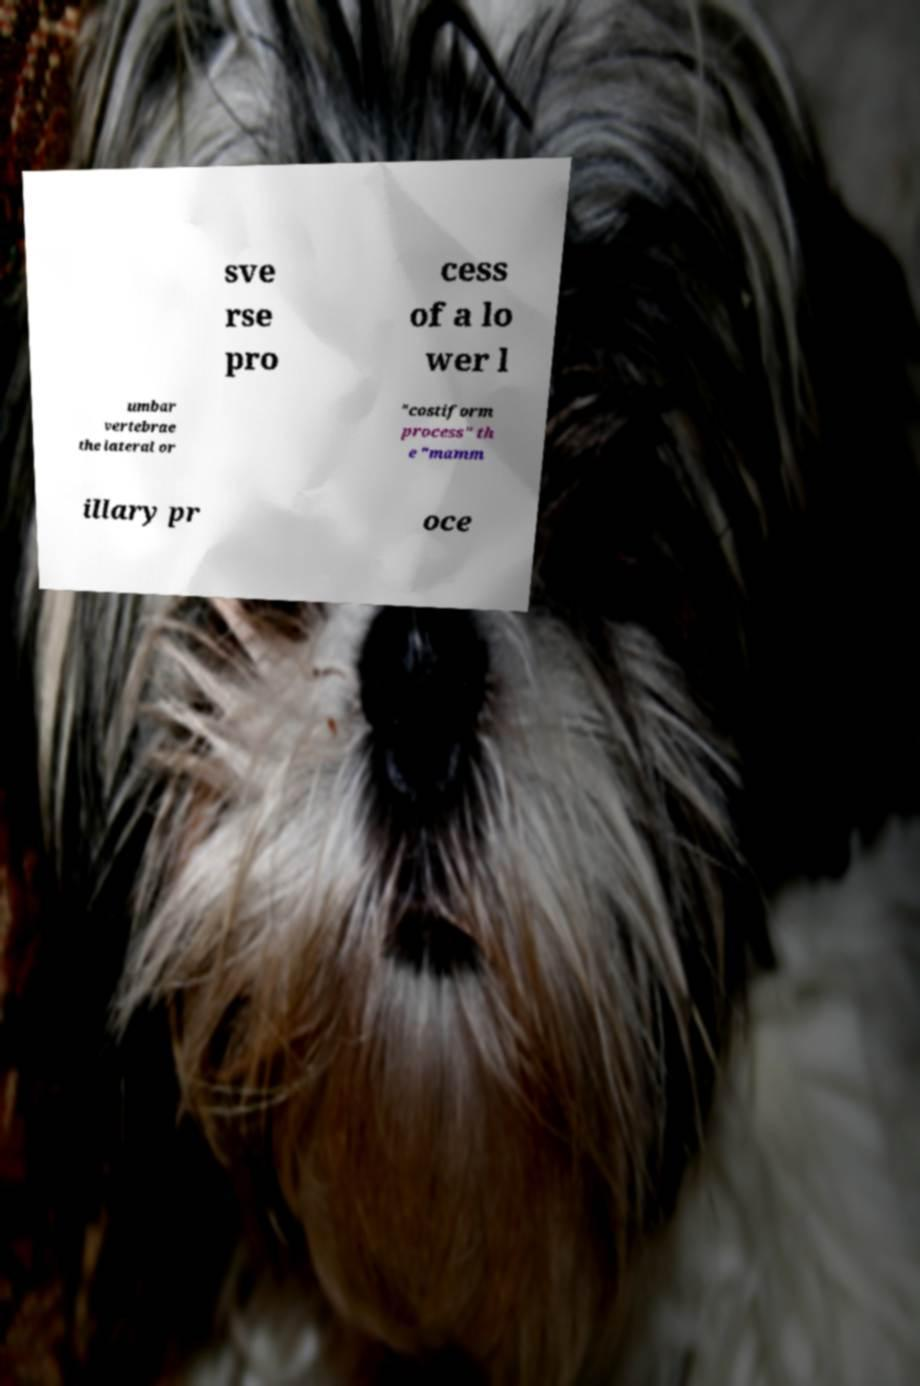Could you extract and type out the text from this image? sve rse pro cess of a lo wer l umbar vertebrae the lateral or "costiform process" th e "mamm illary pr oce 